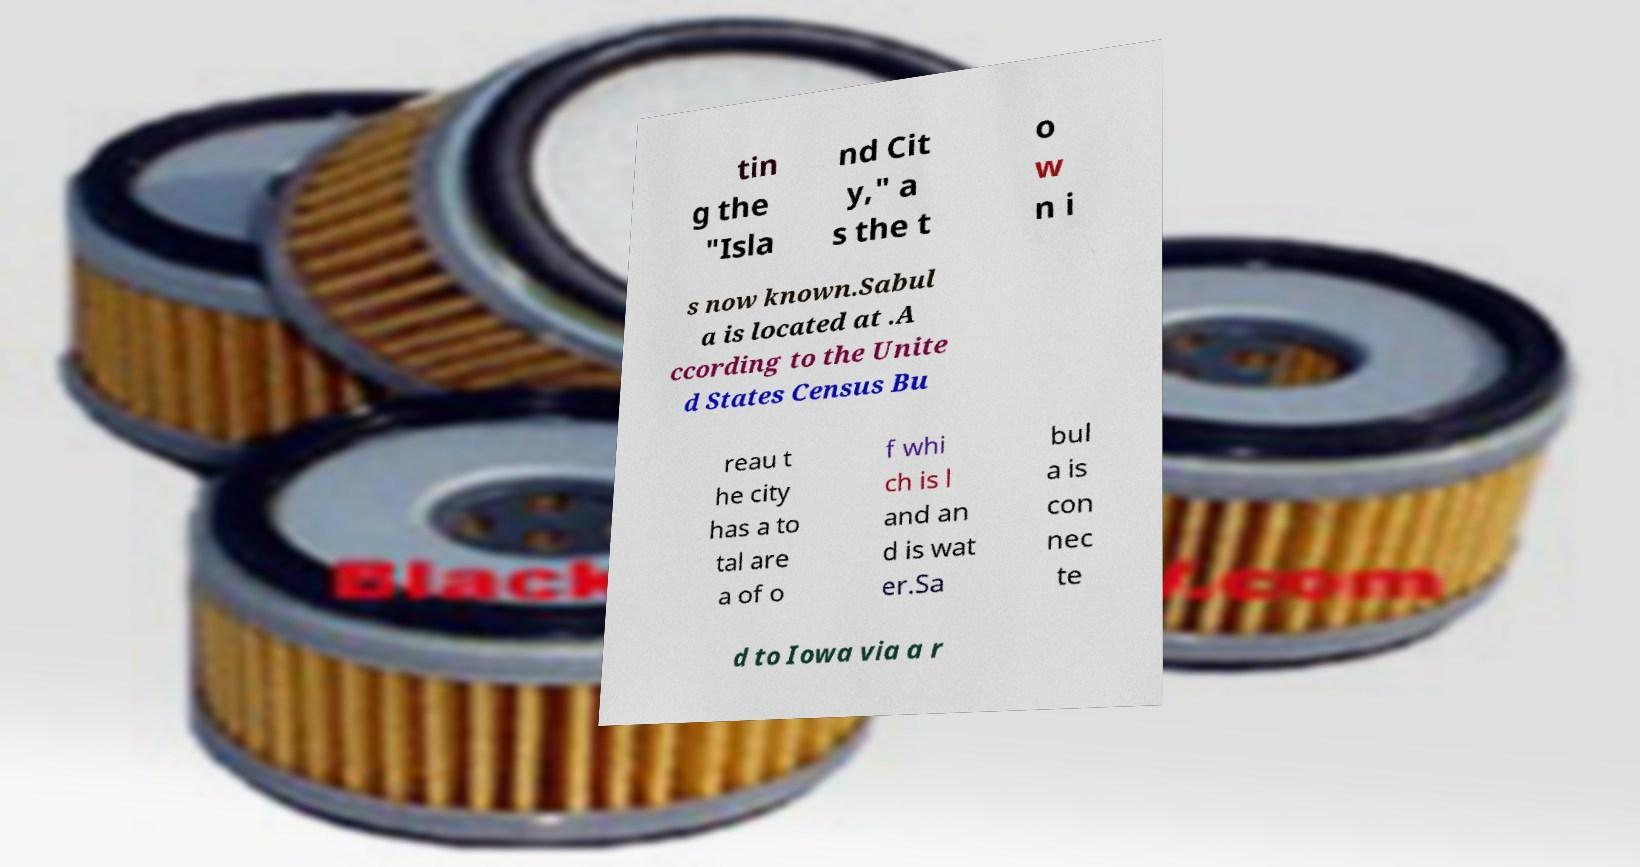I need the written content from this picture converted into text. Can you do that? tin g the "Isla nd Cit y," a s the t o w n i s now known.Sabul a is located at .A ccording to the Unite d States Census Bu reau t he city has a to tal are a of o f whi ch is l and an d is wat er.Sa bul a is con nec te d to Iowa via a r 